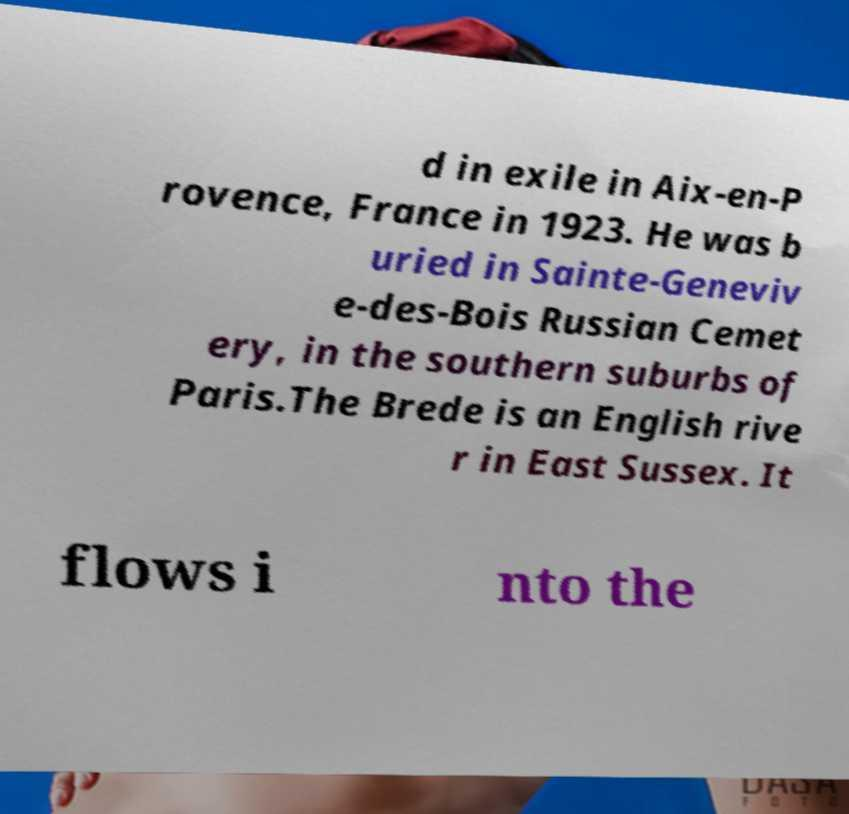What messages or text are displayed in this image? I need them in a readable, typed format. d in exile in Aix-en-P rovence, France in 1923. He was b uried in Sainte-Geneviv e-des-Bois Russian Cemet ery, in the southern suburbs of Paris.The Brede is an English rive r in East Sussex. It flows i nto the 